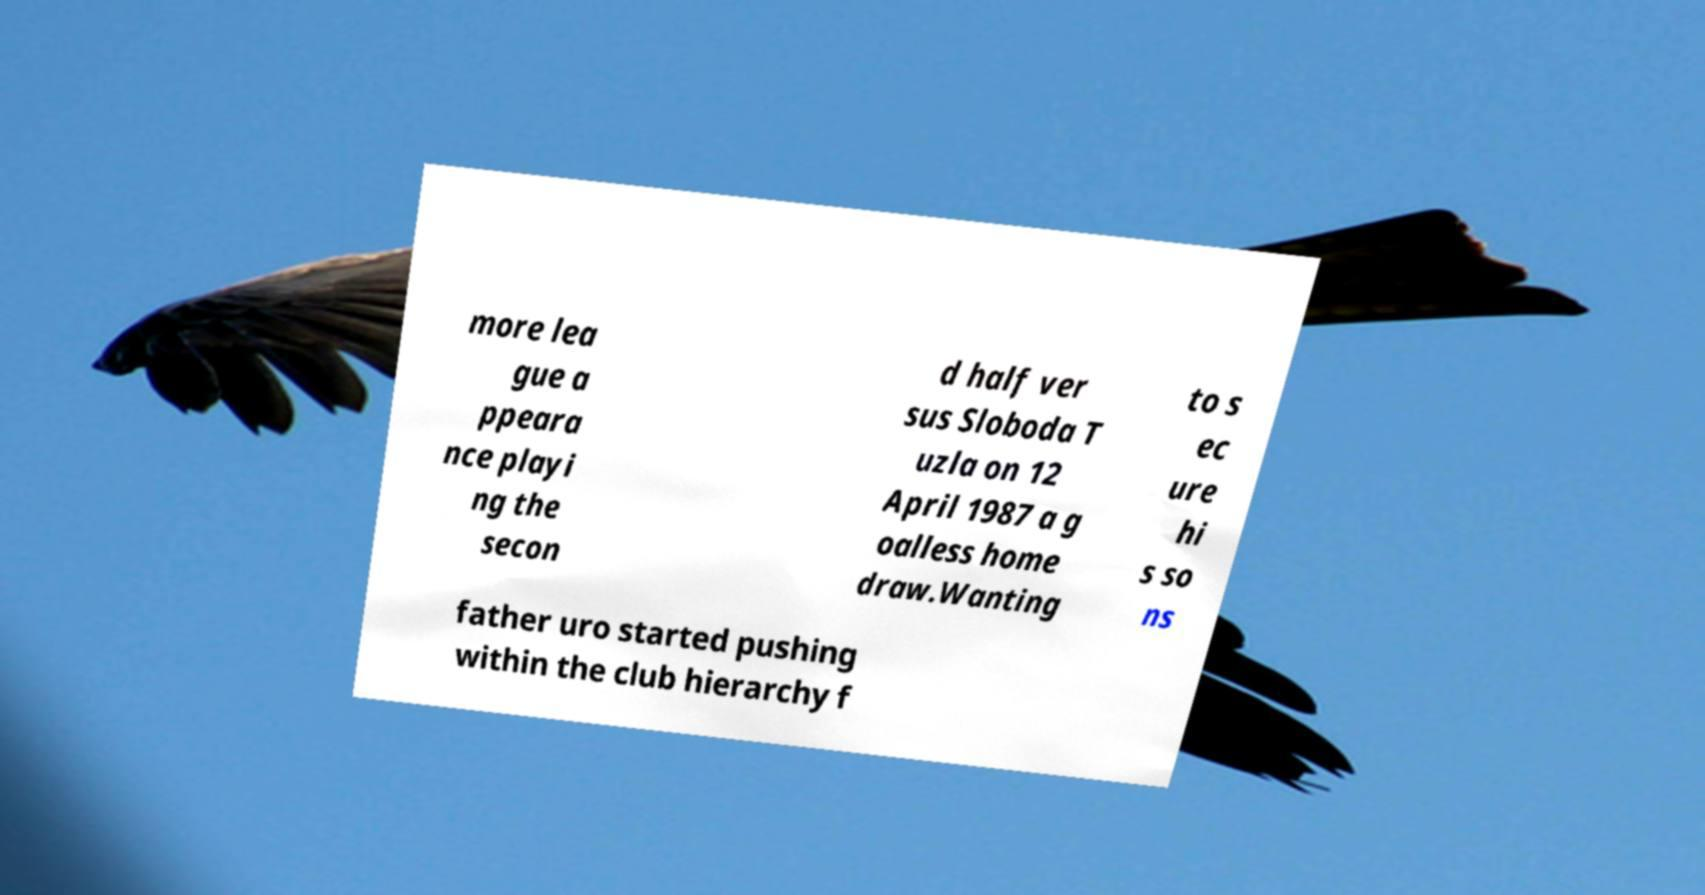Please read and relay the text visible in this image. What does it say? more lea gue a ppeara nce playi ng the secon d half ver sus Sloboda T uzla on 12 April 1987 a g oalless home draw.Wanting to s ec ure hi s so ns father uro started pushing within the club hierarchy f 